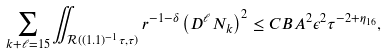Convert formula to latex. <formula><loc_0><loc_0><loc_500><loc_500>\sum _ { k + \ell = 1 5 } \iint _ { \mathcal { R } ( ( 1 . 1 ) ^ { - 1 } \tau , \tau ) } r ^ { - 1 - \delta } \left ( D ^ { \ell } N _ { k } \right ) ^ { 2 } \leq C B A ^ { 2 } \epsilon ^ { 2 } \tau ^ { - 2 + \eta _ { 1 6 } } ,</formula> 